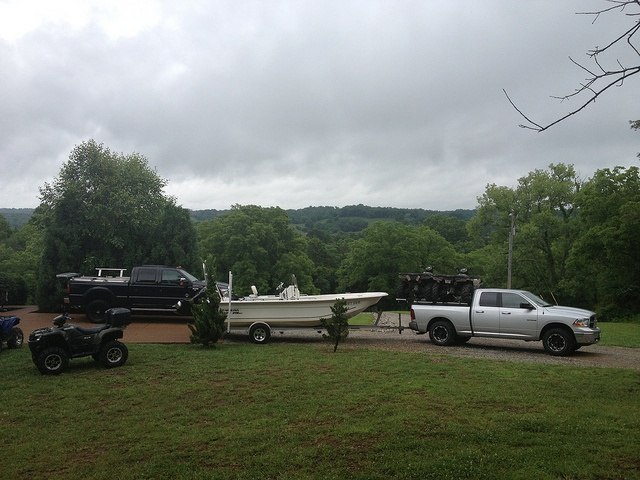Describe the objects in this image and their specific colors. I can see truck in white, black, gray, darkgray, and lightgray tones, boat in white, black, gray, and darkgray tones, truck in white, black, and gray tones, and motorcycle in white, black, and gray tones in this image. 